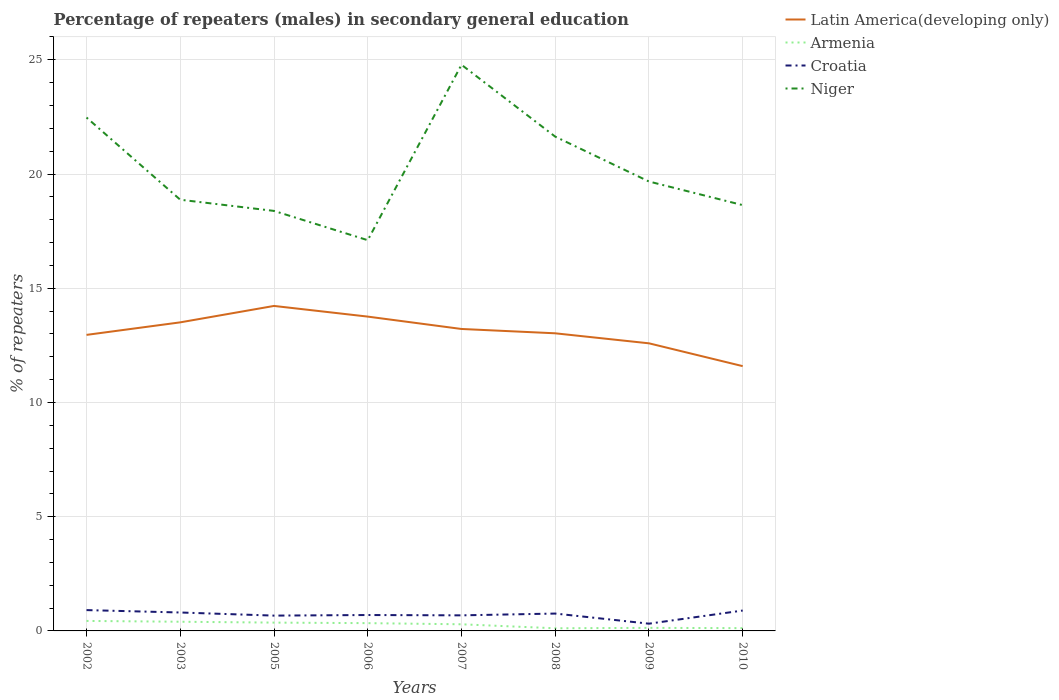How many different coloured lines are there?
Ensure brevity in your answer.  4. Does the line corresponding to Croatia intersect with the line corresponding to Niger?
Give a very brief answer. No. Across all years, what is the maximum percentage of male repeaters in Armenia?
Your response must be concise. 0.12. In which year was the percentage of male repeaters in Latin America(developing only) maximum?
Your answer should be very brief. 2010. What is the total percentage of male repeaters in Croatia in the graph?
Provide a short and direct response. 0.1. What is the difference between the highest and the second highest percentage of male repeaters in Niger?
Make the answer very short. 7.68. What is the difference between the highest and the lowest percentage of male repeaters in Niger?
Your answer should be compact. 3. How many lines are there?
Offer a terse response. 4. Are the values on the major ticks of Y-axis written in scientific E-notation?
Ensure brevity in your answer.  No. Where does the legend appear in the graph?
Provide a succinct answer. Top right. How many legend labels are there?
Provide a succinct answer. 4. How are the legend labels stacked?
Offer a very short reply. Vertical. What is the title of the graph?
Offer a terse response. Percentage of repeaters (males) in secondary general education. Does "Kenya" appear as one of the legend labels in the graph?
Keep it short and to the point. No. What is the label or title of the Y-axis?
Keep it short and to the point. % of repeaters. What is the % of repeaters of Latin America(developing only) in 2002?
Offer a very short reply. 12.96. What is the % of repeaters of Armenia in 2002?
Provide a succinct answer. 0.44. What is the % of repeaters in Croatia in 2002?
Your response must be concise. 0.91. What is the % of repeaters of Niger in 2002?
Give a very brief answer. 22.47. What is the % of repeaters of Latin America(developing only) in 2003?
Offer a terse response. 13.51. What is the % of repeaters of Armenia in 2003?
Provide a short and direct response. 0.4. What is the % of repeaters in Croatia in 2003?
Make the answer very short. 0.81. What is the % of repeaters in Niger in 2003?
Your response must be concise. 18.87. What is the % of repeaters in Latin America(developing only) in 2005?
Your answer should be compact. 14.23. What is the % of repeaters in Armenia in 2005?
Your answer should be compact. 0.36. What is the % of repeaters of Croatia in 2005?
Offer a very short reply. 0.67. What is the % of repeaters of Niger in 2005?
Your response must be concise. 18.39. What is the % of repeaters of Latin America(developing only) in 2006?
Ensure brevity in your answer.  13.76. What is the % of repeaters of Armenia in 2006?
Your answer should be compact. 0.34. What is the % of repeaters of Croatia in 2006?
Give a very brief answer. 0.7. What is the % of repeaters of Niger in 2006?
Make the answer very short. 17.1. What is the % of repeaters of Latin America(developing only) in 2007?
Offer a very short reply. 13.22. What is the % of repeaters of Armenia in 2007?
Give a very brief answer. 0.29. What is the % of repeaters of Croatia in 2007?
Offer a terse response. 0.68. What is the % of repeaters in Niger in 2007?
Offer a very short reply. 24.78. What is the % of repeaters of Latin America(developing only) in 2008?
Keep it short and to the point. 13.03. What is the % of repeaters in Armenia in 2008?
Make the answer very short. 0.12. What is the % of repeaters of Croatia in 2008?
Keep it short and to the point. 0.76. What is the % of repeaters in Niger in 2008?
Keep it short and to the point. 21.64. What is the % of repeaters of Latin America(developing only) in 2009?
Provide a succinct answer. 12.59. What is the % of repeaters in Armenia in 2009?
Your response must be concise. 0.13. What is the % of repeaters of Croatia in 2009?
Your response must be concise. 0.32. What is the % of repeaters of Niger in 2009?
Offer a very short reply. 19.67. What is the % of repeaters of Latin America(developing only) in 2010?
Offer a terse response. 11.59. What is the % of repeaters of Armenia in 2010?
Your answer should be very brief. 0.12. What is the % of repeaters of Croatia in 2010?
Your response must be concise. 0.89. What is the % of repeaters of Niger in 2010?
Your answer should be very brief. 18.64. Across all years, what is the maximum % of repeaters of Latin America(developing only)?
Your answer should be very brief. 14.23. Across all years, what is the maximum % of repeaters in Armenia?
Your response must be concise. 0.44. Across all years, what is the maximum % of repeaters in Croatia?
Provide a succinct answer. 0.91. Across all years, what is the maximum % of repeaters of Niger?
Provide a short and direct response. 24.78. Across all years, what is the minimum % of repeaters in Latin America(developing only)?
Keep it short and to the point. 11.59. Across all years, what is the minimum % of repeaters of Armenia?
Make the answer very short. 0.12. Across all years, what is the minimum % of repeaters in Croatia?
Keep it short and to the point. 0.32. Across all years, what is the minimum % of repeaters in Niger?
Your response must be concise. 17.1. What is the total % of repeaters in Latin America(developing only) in the graph?
Your answer should be compact. 104.88. What is the total % of repeaters of Armenia in the graph?
Give a very brief answer. 2.2. What is the total % of repeaters in Croatia in the graph?
Provide a short and direct response. 5.74. What is the total % of repeaters of Niger in the graph?
Offer a very short reply. 161.57. What is the difference between the % of repeaters of Latin America(developing only) in 2002 and that in 2003?
Your answer should be compact. -0.55. What is the difference between the % of repeaters in Armenia in 2002 and that in 2003?
Your answer should be compact. 0.04. What is the difference between the % of repeaters in Croatia in 2002 and that in 2003?
Keep it short and to the point. 0.1. What is the difference between the % of repeaters of Niger in 2002 and that in 2003?
Offer a terse response. 3.6. What is the difference between the % of repeaters in Latin America(developing only) in 2002 and that in 2005?
Your response must be concise. -1.27. What is the difference between the % of repeaters in Armenia in 2002 and that in 2005?
Make the answer very short. 0.07. What is the difference between the % of repeaters in Croatia in 2002 and that in 2005?
Provide a short and direct response. 0.24. What is the difference between the % of repeaters of Niger in 2002 and that in 2005?
Make the answer very short. 4.09. What is the difference between the % of repeaters in Latin America(developing only) in 2002 and that in 2006?
Your answer should be very brief. -0.8. What is the difference between the % of repeaters in Armenia in 2002 and that in 2006?
Provide a succinct answer. 0.1. What is the difference between the % of repeaters of Croatia in 2002 and that in 2006?
Keep it short and to the point. 0.22. What is the difference between the % of repeaters in Niger in 2002 and that in 2006?
Give a very brief answer. 5.37. What is the difference between the % of repeaters of Latin America(developing only) in 2002 and that in 2007?
Keep it short and to the point. -0.26. What is the difference between the % of repeaters in Armenia in 2002 and that in 2007?
Make the answer very short. 0.15. What is the difference between the % of repeaters in Croatia in 2002 and that in 2007?
Offer a very short reply. 0.23. What is the difference between the % of repeaters of Niger in 2002 and that in 2007?
Your response must be concise. -2.31. What is the difference between the % of repeaters in Latin America(developing only) in 2002 and that in 2008?
Give a very brief answer. -0.07. What is the difference between the % of repeaters in Armenia in 2002 and that in 2008?
Your response must be concise. 0.32. What is the difference between the % of repeaters of Croatia in 2002 and that in 2008?
Make the answer very short. 0.15. What is the difference between the % of repeaters in Niger in 2002 and that in 2008?
Make the answer very short. 0.84. What is the difference between the % of repeaters in Latin America(developing only) in 2002 and that in 2009?
Make the answer very short. 0.37. What is the difference between the % of repeaters of Armenia in 2002 and that in 2009?
Offer a very short reply. 0.3. What is the difference between the % of repeaters in Croatia in 2002 and that in 2009?
Your answer should be compact. 0.59. What is the difference between the % of repeaters in Niger in 2002 and that in 2009?
Provide a succinct answer. 2.8. What is the difference between the % of repeaters in Latin America(developing only) in 2002 and that in 2010?
Give a very brief answer. 1.37. What is the difference between the % of repeaters of Armenia in 2002 and that in 2010?
Make the answer very short. 0.32. What is the difference between the % of repeaters in Croatia in 2002 and that in 2010?
Your answer should be very brief. 0.02. What is the difference between the % of repeaters in Niger in 2002 and that in 2010?
Offer a very short reply. 3.83. What is the difference between the % of repeaters of Latin America(developing only) in 2003 and that in 2005?
Your answer should be very brief. -0.72. What is the difference between the % of repeaters of Armenia in 2003 and that in 2005?
Provide a short and direct response. 0.04. What is the difference between the % of repeaters of Croatia in 2003 and that in 2005?
Your answer should be very brief. 0.14. What is the difference between the % of repeaters in Niger in 2003 and that in 2005?
Give a very brief answer. 0.49. What is the difference between the % of repeaters of Latin America(developing only) in 2003 and that in 2006?
Give a very brief answer. -0.25. What is the difference between the % of repeaters in Armenia in 2003 and that in 2006?
Make the answer very short. 0.06. What is the difference between the % of repeaters of Croatia in 2003 and that in 2006?
Give a very brief answer. 0.11. What is the difference between the % of repeaters of Niger in 2003 and that in 2006?
Give a very brief answer. 1.77. What is the difference between the % of repeaters of Latin America(developing only) in 2003 and that in 2007?
Give a very brief answer. 0.29. What is the difference between the % of repeaters in Armenia in 2003 and that in 2007?
Offer a very short reply. 0.11. What is the difference between the % of repeaters in Croatia in 2003 and that in 2007?
Offer a terse response. 0.12. What is the difference between the % of repeaters of Niger in 2003 and that in 2007?
Ensure brevity in your answer.  -5.91. What is the difference between the % of repeaters of Latin America(developing only) in 2003 and that in 2008?
Ensure brevity in your answer.  0.48. What is the difference between the % of repeaters in Armenia in 2003 and that in 2008?
Your answer should be very brief. 0.29. What is the difference between the % of repeaters of Croatia in 2003 and that in 2008?
Give a very brief answer. 0.05. What is the difference between the % of repeaters in Niger in 2003 and that in 2008?
Your answer should be very brief. -2.76. What is the difference between the % of repeaters in Latin America(developing only) in 2003 and that in 2009?
Ensure brevity in your answer.  0.92. What is the difference between the % of repeaters in Armenia in 2003 and that in 2009?
Keep it short and to the point. 0.27. What is the difference between the % of repeaters of Croatia in 2003 and that in 2009?
Offer a terse response. 0.49. What is the difference between the % of repeaters in Niger in 2003 and that in 2009?
Provide a short and direct response. -0.8. What is the difference between the % of repeaters in Latin America(developing only) in 2003 and that in 2010?
Your response must be concise. 1.92. What is the difference between the % of repeaters in Armenia in 2003 and that in 2010?
Make the answer very short. 0.28. What is the difference between the % of repeaters in Croatia in 2003 and that in 2010?
Your answer should be compact. -0.09. What is the difference between the % of repeaters of Niger in 2003 and that in 2010?
Keep it short and to the point. 0.24. What is the difference between the % of repeaters of Latin America(developing only) in 2005 and that in 2006?
Ensure brevity in your answer.  0.47. What is the difference between the % of repeaters in Armenia in 2005 and that in 2006?
Your answer should be very brief. 0.02. What is the difference between the % of repeaters in Croatia in 2005 and that in 2006?
Offer a terse response. -0.03. What is the difference between the % of repeaters in Niger in 2005 and that in 2006?
Your answer should be compact. 1.28. What is the difference between the % of repeaters in Latin America(developing only) in 2005 and that in 2007?
Your response must be concise. 1.01. What is the difference between the % of repeaters in Armenia in 2005 and that in 2007?
Offer a terse response. 0.07. What is the difference between the % of repeaters in Croatia in 2005 and that in 2007?
Your response must be concise. -0.01. What is the difference between the % of repeaters of Niger in 2005 and that in 2007?
Provide a succinct answer. -6.4. What is the difference between the % of repeaters in Latin America(developing only) in 2005 and that in 2008?
Offer a terse response. 1.2. What is the difference between the % of repeaters of Armenia in 2005 and that in 2008?
Offer a very short reply. 0.25. What is the difference between the % of repeaters of Croatia in 2005 and that in 2008?
Ensure brevity in your answer.  -0.09. What is the difference between the % of repeaters of Niger in 2005 and that in 2008?
Ensure brevity in your answer.  -3.25. What is the difference between the % of repeaters in Latin America(developing only) in 2005 and that in 2009?
Make the answer very short. 1.64. What is the difference between the % of repeaters of Armenia in 2005 and that in 2009?
Offer a very short reply. 0.23. What is the difference between the % of repeaters in Croatia in 2005 and that in 2009?
Provide a succinct answer. 0.35. What is the difference between the % of repeaters in Niger in 2005 and that in 2009?
Your answer should be very brief. -1.29. What is the difference between the % of repeaters in Latin America(developing only) in 2005 and that in 2010?
Your response must be concise. 2.64. What is the difference between the % of repeaters of Armenia in 2005 and that in 2010?
Provide a short and direct response. 0.24. What is the difference between the % of repeaters of Croatia in 2005 and that in 2010?
Your response must be concise. -0.22. What is the difference between the % of repeaters of Niger in 2005 and that in 2010?
Ensure brevity in your answer.  -0.25. What is the difference between the % of repeaters in Latin America(developing only) in 2006 and that in 2007?
Ensure brevity in your answer.  0.54. What is the difference between the % of repeaters of Armenia in 2006 and that in 2007?
Make the answer very short. 0.05. What is the difference between the % of repeaters of Croatia in 2006 and that in 2007?
Offer a very short reply. 0.01. What is the difference between the % of repeaters in Niger in 2006 and that in 2007?
Your response must be concise. -7.68. What is the difference between the % of repeaters in Latin America(developing only) in 2006 and that in 2008?
Provide a succinct answer. 0.73. What is the difference between the % of repeaters of Armenia in 2006 and that in 2008?
Your answer should be very brief. 0.23. What is the difference between the % of repeaters in Croatia in 2006 and that in 2008?
Your answer should be compact. -0.06. What is the difference between the % of repeaters in Niger in 2006 and that in 2008?
Keep it short and to the point. -4.53. What is the difference between the % of repeaters in Latin America(developing only) in 2006 and that in 2009?
Offer a terse response. 1.17. What is the difference between the % of repeaters of Armenia in 2006 and that in 2009?
Offer a very short reply. 0.21. What is the difference between the % of repeaters in Croatia in 2006 and that in 2009?
Give a very brief answer. 0.38. What is the difference between the % of repeaters in Niger in 2006 and that in 2009?
Your response must be concise. -2.57. What is the difference between the % of repeaters of Latin America(developing only) in 2006 and that in 2010?
Provide a short and direct response. 2.17. What is the difference between the % of repeaters of Armenia in 2006 and that in 2010?
Offer a terse response. 0.22. What is the difference between the % of repeaters of Croatia in 2006 and that in 2010?
Give a very brief answer. -0.2. What is the difference between the % of repeaters of Niger in 2006 and that in 2010?
Keep it short and to the point. -1.54. What is the difference between the % of repeaters of Latin America(developing only) in 2007 and that in 2008?
Offer a terse response. 0.19. What is the difference between the % of repeaters in Armenia in 2007 and that in 2008?
Ensure brevity in your answer.  0.18. What is the difference between the % of repeaters of Croatia in 2007 and that in 2008?
Offer a very short reply. -0.08. What is the difference between the % of repeaters of Niger in 2007 and that in 2008?
Make the answer very short. 3.15. What is the difference between the % of repeaters of Latin America(developing only) in 2007 and that in 2009?
Give a very brief answer. 0.63. What is the difference between the % of repeaters of Armenia in 2007 and that in 2009?
Provide a succinct answer. 0.16. What is the difference between the % of repeaters in Croatia in 2007 and that in 2009?
Offer a terse response. 0.36. What is the difference between the % of repeaters of Niger in 2007 and that in 2009?
Keep it short and to the point. 5.11. What is the difference between the % of repeaters in Latin America(developing only) in 2007 and that in 2010?
Make the answer very short. 1.63. What is the difference between the % of repeaters in Armenia in 2007 and that in 2010?
Keep it short and to the point. 0.17. What is the difference between the % of repeaters of Croatia in 2007 and that in 2010?
Keep it short and to the point. -0.21. What is the difference between the % of repeaters of Niger in 2007 and that in 2010?
Ensure brevity in your answer.  6.14. What is the difference between the % of repeaters in Latin America(developing only) in 2008 and that in 2009?
Offer a very short reply. 0.44. What is the difference between the % of repeaters of Armenia in 2008 and that in 2009?
Give a very brief answer. -0.02. What is the difference between the % of repeaters in Croatia in 2008 and that in 2009?
Keep it short and to the point. 0.44. What is the difference between the % of repeaters of Niger in 2008 and that in 2009?
Ensure brevity in your answer.  1.96. What is the difference between the % of repeaters of Latin America(developing only) in 2008 and that in 2010?
Your answer should be very brief. 1.44. What is the difference between the % of repeaters in Armenia in 2008 and that in 2010?
Keep it short and to the point. -0.01. What is the difference between the % of repeaters of Croatia in 2008 and that in 2010?
Provide a succinct answer. -0.13. What is the difference between the % of repeaters of Niger in 2008 and that in 2010?
Make the answer very short. 3. What is the difference between the % of repeaters in Latin America(developing only) in 2009 and that in 2010?
Your response must be concise. 1. What is the difference between the % of repeaters of Armenia in 2009 and that in 2010?
Your answer should be compact. 0.01. What is the difference between the % of repeaters in Croatia in 2009 and that in 2010?
Offer a very short reply. -0.58. What is the difference between the % of repeaters in Niger in 2009 and that in 2010?
Make the answer very short. 1.03. What is the difference between the % of repeaters in Latin America(developing only) in 2002 and the % of repeaters in Armenia in 2003?
Make the answer very short. 12.56. What is the difference between the % of repeaters of Latin America(developing only) in 2002 and the % of repeaters of Croatia in 2003?
Make the answer very short. 12.15. What is the difference between the % of repeaters in Latin America(developing only) in 2002 and the % of repeaters in Niger in 2003?
Ensure brevity in your answer.  -5.92. What is the difference between the % of repeaters of Armenia in 2002 and the % of repeaters of Croatia in 2003?
Offer a terse response. -0.37. What is the difference between the % of repeaters of Armenia in 2002 and the % of repeaters of Niger in 2003?
Offer a terse response. -18.44. What is the difference between the % of repeaters of Croatia in 2002 and the % of repeaters of Niger in 2003?
Offer a very short reply. -17.96. What is the difference between the % of repeaters of Latin America(developing only) in 2002 and the % of repeaters of Armenia in 2005?
Your answer should be compact. 12.59. What is the difference between the % of repeaters of Latin America(developing only) in 2002 and the % of repeaters of Croatia in 2005?
Provide a succinct answer. 12.29. What is the difference between the % of repeaters in Latin America(developing only) in 2002 and the % of repeaters in Niger in 2005?
Provide a succinct answer. -5.43. What is the difference between the % of repeaters in Armenia in 2002 and the % of repeaters in Croatia in 2005?
Ensure brevity in your answer.  -0.23. What is the difference between the % of repeaters of Armenia in 2002 and the % of repeaters of Niger in 2005?
Give a very brief answer. -17.95. What is the difference between the % of repeaters in Croatia in 2002 and the % of repeaters in Niger in 2005?
Ensure brevity in your answer.  -17.47. What is the difference between the % of repeaters in Latin America(developing only) in 2002 and the % of repeaters in Armenia in 2006?
Your answer should be compact. 12.62. What is the difference between the % of repeaters in Latin America(developing only) in 2002 and the % of repeaters in Croatia in 2006?
Offer a very short reply. 12.26. What is the difference between the % of repeaters of Latin America(developing only) in 2002 and the % of repeaters of Niger in 2006?
Your response must be concise. -4.14. What is the difference between the % of repeaters in Armenia in 2002 and the % of repeaters in Croatia in 2006?
Provide a succinct answer. -0.26. What is the difference between the % of repeaters of Armenia in 2002 and the % of repeaters of Niger in 2006?
Your response must be concise. -16.67. What is the difference between the % of repeaters in Croatia in 2002 and the % of repeaters in Niger in 2006?
Offer a very short reply. -16.19. What is the difference between the % of repeaters in Latin America(developing only) in 2002 and the % of repeaters in Armenia in 2007?
Provide a short and direct response. 12.67. What is the difference between the % of repeaters in Latin America(developing only) in 2002 and the % of repeaters in Croatia in 2007?
Provide a succinct answer. 12.28. What is the difference between the % of repeaters of Latin America(developing only) in 2002 and the % of repeaters of Niger in 2007?
Make the answer very short. -11.83. What is the difference between the % of repeaters of Armenia in 2002 and the % of repeaters of Croatia in 2007?
Make the answer very short. -0.24. What is the difference between the % of repeaters in Armenia in 2002 and the % of repeaters in Niger in 2007?
Offer a terse response. -24.35. What is the difference between the % of repeaters of Croatia in 2002 and the % of repeaters of Niger in 2007?
Provide a short and direct response. -23.87. What is the difference between the % of repeaters of Latin America(developing only) in 2002 and the % of repeaters of Armenia in 2008?
Your response must be concise. 12.84. What is the difference between the % of repeaters in Latin America(developing only) in 2002 and the % of repeaters in Croatia in 2008?
Keep it short and to the point. 12.2. What is the difference between the % of repeaters in Latin America(developing only) in 2002 and the % of repeaters in Niger in 2008?
Provide a short and direct response. -8.68. What is the difference between the % of repeaters of Armenia in 2002 and the % of repeaters of Croatia in 2008?
Provide a short and direct response. -0.32. What is the difference between the % of repeaters of Armenia in 2002 and the % of repeaters of Niger in 2008?
Your answer should be very brief. -21.2. What is the difference between the % of repeaters of Croatia in 2002 and the % of repeaters of Niger in 2008?
Your answer should be very brief. -20.73. What is the difference between the % of repeaters of Latin America(developing only) in 2002 and the % of repeaters of Armenia in 2009?
Provide a short and direct response. 12.82. What is the difference between the % of repeaters in Latin America(developing only) in 2002 and the % of repeaters in Croatia in 2009?
Your answer should be compact. 12.64. What is the difference between the % of repeaters in Latin America(developing only) in 2002 and the % of repeaters in Niger in 2009?
Make the answer very short. -6.71. What is the difference between the % of repeaters of Armenia in 2002 and the % of repeaters of Croatia in 2009?
Provide a succinct answer. 0.12. What is the difference between the % of repeaters of Armenia in 2002 and the % of repeaters of Niger in 2009?
Make the answer very short. -19.23. What is the difference between the % of repeaters in Croatia in 2002 and the % of repeaters in Niger in 2009?
Keep it short and to the point. -18.76. What is the difference between the % of repeaters of Latin America(developing only) in 2002 and the % of repeaters of Armenia in 2010?
Ensure brevity in your answer.  12.84. What is the difference between the % of repeaters in Latin America(developing only) in 2002 and the % of repeaters in Croatia in 2010?
Keep it short and to the point. 12.07. What is the difference between the % of repeaters of Latin America(developing only) in 2002 and the % of repeaters of Niger in 2010?
Your answer should be compact. -5.68. What is the difference between the % of repeaters in Armenia in 2002 and the % of repeaters in Croatia in 2010?
Your response must be concise. -0.46. What is the difference between the % of repeaters of Armenia in 2002 and the % of repeaters of Niger in 2010?
Provide a succinct answer. -18.2. What is the difference between the % of repeaters of Croatia in 2002 and the % of repeaters of Niger in 2010?
Give a very brief answer. -17.73. What is the difference between the % of repeaters in Latin America(developing only) in 2003 and the % of repeaters in Armenia in 2005?
Provide a succinct answer. 13.14. What is the difference between the % of repeaters in Latin America(developing only) in 2003 and the % of repeaters in Croatia in 2005?
Give a very brief answer. 12.84. What is the difference between the % of repeaters of Latin America(developing only) in 2003 and the % of repeaters of Niger in 2005?
Make the answer very short. -4.88. What is the difference between the % of repeaters of Armenia in 2003 and the % of repeaters of Croatia in 2005?
Your response must be concise. -0.27. What is the difference between the % of repeaters in Armenia in 2003 and the % of repeaters in Niger in 2005?
Provide a short and direct response. -17.98. What is the difference between the % of repeaters of Croatia in 2003 and the % of repeaters of Niger in 2005?
Your response must be concise. -17.58. What is the difference between the % of repeaters in Latin America(developing only) in 2003 and the % of repeaters in Armenia in 2006?
Your response must be concise. 13.17. What is the difference between the % of repeaters in Latin America(developing only) in 2003 and the % of repeaters in Croatia in 2006?
Make the answer very short. 12.81. What is the difference between the % of repeaters in Latin America(developing only) in 2003 and the % of repeaters in Niger in 2006?
Ensure brevity in your answer.  -3.6. What is the difference between the % of repeaters of Armenia in 2003 and the % of repeaters of Croatia in 2006?
Offer a very short reply. -0.29. What is the difference between the % of repeaters in Armenia in 2003 and the % of repeaters in Niger in 2006?
Keep it short and to the point. -16.7. What is the difference between the % of repeaters in Croatia in 2003 and the % of repeaters in Niger in 2006?
Your answer should be compact. -16.3. What is the difference between the % of repeaters of Latin America(developing only) in 2003 and the % of repeaters of Armenia in 2007?
Your response must be concise. 13.22. What is the difference between the % of repeaters in Latin America(developing only) in 2003 and the % of repeaters in Croatia in 2007?
Your answer should be compact. 12.83. What is the difference between the % of repeaters of Latin America(developing only) in 2003 and the % of repeaters of Niger in 2007?
Your response must be concise. -11.28. What is the difference between the % of repeaters of Armenia in 2003 and the % of repeaters of Croatia in 2007?
Your answer should be very brief. -0.28. What is the difference between the % of repeaters of Armenia in 2003 and the % of repeaters of Niger in 2007?
Make the answer very short. -24.38. What is the difference between the % of repeaters in Croatia in 2003 and the % of repeaters in Niger in 2007?
Your answer should be compact. -23.98. What is the difference between the % of repeaters of Latin America(developing only) in 2003 and the % of repeaters of Armenia in 2008?
Your answer should be very brief. 13.39. What is the difference between the % of repeaters of Latin America(developing only) in 2003 and the % of repeaters of Croatia in 2008?
Offer a terse response. 12.75. What is the difference between the % of repeaters in Latin America(developing only) in 2003 and the % of repeaters in Niger in 2008?
Your response must be concise. -8.13. What is the difference between the % of repeaters in Armenia in 2003 and the % of repeaters in Croatia in 2008?
Give a very brief answer. -0.36. What is the difference between the % of repeaters in Armenia in 2003 and the % of repeaters in Niger in 2008?
Provide a succinct answer. -21.24. What is the difference between the % of repeaters of Croatia in 2003 and the % of repeaters of Niger in 2008?
Provide a succinct answer. -20.83. What is the difference between the % of repeaters of Latin America(developing only) in 2003 and the % of repeaters of Armenia in 2009?
Ensure brevity in your answer.  13.37. What is the difference between the % of repeaters in Latin America(developing only) in 2003 and the % of repeaters in Croatia in 2009?
Your answer should be very brief. 13.19. What is the difference between the % of repeaters in Latin America(developing only) in 2003 and the % of repeaters in Niger in 2009?
Provide a short and direct response. -6.16. What is the difference between the % of repeaters in Armenia in 2003 and the % of repeaters in Croatia in 2009?
Provide a short and direct response. 0.08. What is the difference between the % of repeaters in Armenia in 2003 and the % of repeaters in Niger in 2009?
Ensure brevity in your answer.  -19.27. What is the difference between the % of repeaters of Croatia in 2003 and the % of repeaters of Niger in 2009?
Make the answer very short. -18.87. What is the difference between the % of repeaters of Latin America(developing only) in 2003 and the % of repeaters of Armenia in 2010?
Your answer should be very brief. 13.39. What is the difference between the % of repeaters in Latin America(developing only) in 2003 and the % of repeaters in Croatia in 2010?
Offer a terse response. 12.62. What is the difference between the % of repeaters in Latin America(developing only) in 2003 and the % of repeaters in Niger in 2010?
Offer a terse response. -5.13. What is the difference between the % of repeaters in Armenia in 2003 and the % of repeaters in Croatia in 2010?
Keep it short and to the point. -0.49. What is the difference between the % of repeaters of Armenia in 2003 and the % of repeaters of Niger in 2010?
Make the answer very short. -18.24. What is the difference between the % of repeaters of Croatia in 2003 and the % of repeaters of Niger in 2010?
Your answer should be compact. -17.83. What is the difference between the % of repeaters of Latin America(developing only) in 2005 and the % of repeaters of Armenia in 2006?
Make the answer very short. 13.89. What is the difference between the % of repeaters of Latin America(developing only) in 2005 and the % of repeaters of Croatia in 2006?
Offer a very short reply. 13.53. What is the difference between the % of repeaters of Latin America(developing only) in 2005 and the % of repeaters of Niger in 2006?
Make the answer very short. -2.88. What is the difference between the % of repeaters in Armenia in 2005 and the % of repeaters in Croatia in 2006?
Provide a short and direct response. -0.33. What is the difference between the % of repeaters of Armenia in 2005 and the % of repeaters of Niger in 2006?
Provide a succinct answer. -16.74. What is the difference between the % of repeaters of Croatia in 2005 and the % of repeaters of Niger in 2006?
Offer a terse response. -16.43. What is the difference between the % of repeaters of Latin America(developing only) in 2005 and the % of repeaters of Armenia in 2007?
Provide a short and direct response. 13.94. What is the difference between the % of repeaters of Latin America(developing only) in 2005 and the % of repeaters of Croatia in 2007?
Your answer should be very brief. 13.54. What is the difference between the % of repeaters in Latin America(developing only) in 2005 and the % of repeaters in Niger in 2007?
Make the answer very short. -10.56. What is the difference between the % of repeaters in Armenia in 2005 and the % of repeaters in Croatia in 2007?
Offer a very short reply. -0.32. What is the difference between the % of repeaters in Armenia in 2005 and the % of repeaters in Niger in 2007?
Provide a succinct answer. -24.42. What is the difference between the % of repeaters in Croatia in 2005 and the % of repeaters in Niger in 2007?
Provide a short and direct response. -24.11. What is the difference between the % of repeaters of Latin America(developing only) in 2005 and the % of repeaters of Armenia in 2008?
Your answer should be very brief. 14.11. What is the difference between the % of repeaters in Latin America(developing only) in 2005 and the % of repeaters in Croatia in 2008?
Your answer should be compact. 13.47. What is the difference between the % of repeaters of Latin America(developing only) in 2005 and the % of repeaters of Niger in 2008?
Offer a terse response. -7.41. What is the difference between the % of repeaters of Armenia in 2005 and the % of repeaters of Croatia in 2008?
Make the answer very short. -0.4. What is the difference between the % of repeaters of Armenia in 2005 and the % of repeaters of Niger in 2008?
Provide a short and direct response. -21.27. What is the difference between the % of repeaters in Croatia in 2005 and the % of repeaters in Niger in 2008?
Ensure brevity in your answer.  -20.97. What is the difference between the % of repeaters of Latin America(developing only) in 2005 and the % of repeaters of Armenia in 2009?
Your answer should be very brief. 14.09. What is the difference between the % of repeaters in Latin America(developing only) in 2005 and the % of repeaters in Croatia in 2009?
Your response must be concise. 13.91. What is the difference between the % of repeaters of Latin America(developing only) in 2005 and the % of repeaters of Niger in 2009?
Provide a succinct answer. -5.45. What is the difference between the % of repeaters of Armenia in 2005 and the % of repeaters of Croatia in 2009?
Keep it short and to the point. 0.05. What is the difference between the % of repeaters in Armenia in 2005 and the % of repeaters in Niger in 2009?
Provide a short and direct response. -19.31. What is the difference between the % of repeaters in Croatia in 2005 and the % of repeaters in Niger in 2009?
Keep it short and to the point. -19. What is the difference between the % of repeaters of Latin America(developing only) in 2005 and the % of repeaters of Armenia in 2010?
Provide a succinct answer. 14.1. What is the difference between the % of repeaters of Latin America(developing only) in 2005 and the % of repeaters of Croatia in 2010?
Your answer should be compact. 13.33. What is the difference between the % of repeaters of Latin America(developing only) in 2005 and the % of repeaters of Niger in 2010?
Your response must be concise. -4.41. What is the difference between the % of repeaters in Armenia in 2005 and the % of repeaters in Croatia in 2010?
Keep it short and to the point. -0.53. What is the difference between the % of repeaters in Armenia in 2005 and the % of repeaters in Niger in 2010?
Provide a succinct answer. -18.28. What is the difference between the % of repeaters of Croatia in 2005 and the % of repeaters of Niger in 2010?
Provide a succinct answer. -17.97. What is the difference between the % of repeaters in Latin America(developing only) in 2006 and the % of repeaters in Armenia in 2007?
Keep it short and to the point. 13.47. What is the difference between the % of repeaters in Latin America(developing only) in 2006 and the % of repeaters in Croatia in 2007?
Make the answer very short. 13.08. What is the difference between the % of repeaters in Latin America(developing only) in 2006 and the % of repeaters in Niger in 2007?
Give a very brief answer. -11.02. What is the difference between the % of repeaters of Armenia in 2006 and the % of repeaters of Croatia in 2007?
Your response must be concise. -0.34. What is the difference between the % of repeaters of Armenia in 2006 and the % of repeaters of Niger in 2007?
Your answer should be compact. -24.44. What is the difference between the % of repeaters in Croatia in 2006 and the % of repeaters in Niger in 2007?
Provide a succinct answer. -24.09. What is the difference between the % of repeaters of Latin America(developing only) in 2006 and the % of repeaters of Armenia in 2008?
Provide a short and direct response. 13.64. What is the difference between the % of repeaters in Latin America(developing only) in 2006 and the % of repeaters in Croatia in 2008?
Ensure brevity in your answer.  13. What is the difference between the % of repeaters in Latin America(developing only) in 2006 and the % of repeaters in Niger in 2008?
Give a very brief answer. -7.88. What is the difference between the % of repeaters in Armenia in 2006 and the % of repeaters in Croatia in 2008?
Offer a very short reply. -0.42. What is the difference between the % of repeaters of Armenia in 2006 and the % of repeaters of Niger in 2008?
Your answer should be very brief. -21.3. What is the difference between the % of repeaters in Croatia in 2006 and the % of repeaters in Niger in 2008?
Ensure brevity in your answer.  -20.94. What is the difference between the % of repeaters in Latin America(developing only) in 2006 and the % of repeaters in Armenia in 2009?
Make the answer very short. 13.62. What is the difference between the % of repeaters of Latin America(developing only) in 2006 and the % of repeaters of Croatia in 2009?
Your answer should be compact. 13.44. What is the difference between the % of repeaters of Latin America(developing only) in 2006 and the % of repeaters of Niger in 2009?
Your answer should be very brief. -5.91. What is the difference between the % of repeaters in Armenia in 2006 and the % of repeaters in Croatia in 2009?
Provide a short and direct response. 0.02. What is the difference between the % of repeaters in Armenia in 2006 and the % of repeaters in Niger in 2009?
Offer a terse response. -19.33. What is the difference between the % of repeaters of Croatia in 2006 and the % of repeaters of Niger in 2009?
Offer a terse response. -18.98. What is the difference between the % of repeaters of Latin America(developing only) in 2006 and the % of repeaters of Armenia in 2010?
Keep it short and to the point. 13.64. What is the difference between the % of repeaters in Latin America(developing only) in 2006 and the % of repeaters in Croatia in 2010?
Provide a succinct answer. 12.87. What is the difference between the % of repeaters of Latin America(developing only) in 2006 and the % of repeaters of Niger in 2010?
Keep it short and to the point. -4.88. What is the difference between the % of repeaters in Armenia in 2006 and the % of repeaters in Croatia in 2010?
Ensure brevity in your answer.  -0.55. What is the difference between the % of repeaters in Armenia in 2006 and the % of repeaters in Niger in 2010?
Provide a succinct answer. -18.3. What is the difference between the % of repeaters of Croatia in 2006 and the % of repeaters of Niger in 2010?
Provide a short and direct response. -17.94. What is the difference between the % of repeaters of Latin America(developing only) in 2007 and the % of repeaters of Armenia in 2008?
Ensure brevity in your answer.  13.1. What is the difference between the % of repeaters of Latin America(developing only) in 2007 and the % of repeaters of Croatia in 2008?
Ensure brevity in your answer.  12.46. What is the difference between the % of repeaters in Latin America(developing only) in 2007 and the % of repeaters in Niger in 2008?
Offer a terse response. -8.42. What is the difference between the % of repeaters of Armenia in 2007 and the % of repeaters of Croatia in 2008?
Provide a short and direct response. -0.47. What is the difference between the % of repeaters in Armenia in 2007 and the % of repeaters in Niger in 2008?
Keep it short and to the point. -21.35. What is the difference between the % of repeaters in Croatia in 2007 and the % of repeaters in Niger in 2008?
Offer a terse response. -20.96. What is the difference between the % of repeaters in Latin America(developing only) in 2007 and the % of repeaters in Armenia in 2009?
Provide a short and direct response. 13.08. What is the difference between the % of repeaters in Latin America(developing only) in 2007 and the % of repeaters in Croatia in 2009?
Your response must be concise. 12.9. What is the difference between the % of repeaters in Latin America(developing only) in 2007 and the % of repeaters in Niger in 2009?
Your answer should be compact. -6.45. What is the difference between the % of repeaters in Armenia in 2007 and the % of repeaters in Croatia in 2009?
Make the answer very short. -0.03. What is the difference between the % of repeaters in Armenia in 2007 and the % of repeaters in Niger in 2009?
Keep it short and to the point. -19.38. What is the difference between the % of repeaters of Croatia in 2007 and the % of repeaters of Niger in 2009?
Keep it short and to the point. -18.99. What is the difference between the % of repeaters of Latin America(developing only) in 2007 and the % of repeaters of Armenia in 2010?
Your answer should be compact. 13.1. What is the difference between the % of repeaters of Latin America(developing only) in 2007 and the % of repeaters of Croatia in 2010?
Give a very brief answer. 12.33. What is the difference between the % of repeaters in Latin America(developing only) in 2007 and the % of repeaters in Niger in 2010?
Offer a terse response. -5.42. What is the difference between the % of repeaters of Armenia in 2007 and the % of repeaters of Croatia in 2010?
Provide a short and direct response. -0.6. What is the difference between the % of repeaters of Armenia in 2007 and the % of repeaters of Niger in 2010?
Your answer should be compact. -18.35. What is the difference between the % of repeaters in Croatia in 2007 and the % of repeaters in Niger in 2010?
Your answer should be very brief. -17.96. What is the difference between the % of repeaters of Latin America(developing only) in 2008 and the % of repeaters of Armenia in 2009?
Make the answer very short. 12.89. What is the difference between the % of repeaters of Latin America(developing only) in 2008 and the % of repeaters of Croatia in 2009?
Provide a succinct answer. 12.71. What is the difference between the % of repeaters of Latin America(developing only) in 2008 and the % of repeaters of Niger in 2009?
Give a very brief answer. -6.64. What is the difference between the % of repeaters in Armenia in 2008 and the % of repeaters in Croatia in 2009?
Your answer should be compact. -0.2. What is the difference between the % of repeaters of Armenia in 2008 and the % of repeaters of Niger in 2009?
Your answer should be very brief. -19.56. What is the difference between the % of repeaters in Croatia in 2008 and the % of repeaters in Niger in 2009?
Offer a very short reply. -18.91. What is the difference between the % of repeaters of Latin America(developing only) in 2008 and the % of repeaters of Armenia in 2010?
Make the answer very short. 12.91. What is the difference between the % of repeaters of Latin America(developing only) in 2008 and the % of repeaters of Croatia in 2010?
Your answer should be very brief. 12.14. What is the difference between the % of repeaters in Latin America(developing only) in 2008 and the % of repeaters in Niger in 2010?
Ensure brevity in your answer.  -5.61. What is the difference between the % of repeaters of Armenia in 2008 and the % of repeaters of Croatia in 2010?
Your answer should be very brief. -0.78. What is the difference between the % of repeaters in Armenia in 2008 and the % of repeaters in Niger in 2010?
Your response must be concise. -18.52. What is the difference between the % of repeaters of Croatia in 2008 and the % of repeaters of Niger in 2010?
Give a very brief answer. -17.88. What is the difference between the % of repeaters in Latin America(developing only) in 2009 and the % of repeaters in Armenia in 2010?
Your answer should be very brief. 12.47. What is the difference between the % of repeaters of Latin America(developing only) in 2009 and the % of repeaters of Croatia in 2010?
Ensure brevity in your answer.  11.7. What is the difference between the % of repeaters of Latin America(developing only) in 2009 and the % of repeaters of Niger in 2010?
Your answer should be very brief. -6.05. What is the difference between the % of repeaters of Armenia in 2009 and the % of repeaters of Croatia in 2010?
Your answer should be compact. -0.76. What is the difference between the % of repeaters of Armenia in 2009 and the % of repeaters of Niger in 2010?
Provide a short and direct response. -18.5. What is the difference between the % of repeaters in Croatia in 2009 and the % of repeaters in Niger in 2010?
Keep it short and to the point. -18.32. What is the average % of repeaters in Latin America(developing only) per year?
Ensure brevity in your answer.  13.11. What is the average % of repeaters in Armenia per year?
Offer a very short reply. 0.28. What is the average % of repeaters of Croatia per year?
Ensure brevity in your answer.  0.72. What is the average % of repeaters in Niger per year?
Your response must be concise. 20.2. In the year 2002, what is the difference between the % of repeaters of Latin America(developing only) and % of repeaters of Armenia?
Provide a succinct answer. 12.52. In the year 2002, what is the difference between the % of repeaters of Latin America(developing only) and % of repeaters of Croatia?
Keep it short and to the point. 12.05. In the year 2002, what is the difference between the % of repeaters in Latin America(developing only) and % of repeaters in Niger?
Your answer should be compact. -9.51. In the year 2002, what is the difference between the % of repeaters of Armenia and % of repeaters of Croatia?
Your response must be concise. -0.47. In the year 2002, what is the difference between the % of repeaters in Armenia and % of repeaters in Niger?
Your answer should be compact. -22.04. In the year 2002, what is the difference between the % of repeaters of Croatia and % of repeaters of Niger?
Provide a short and direct response. -21.56. In the year 2003, what is the difference between the % of repeaters of Latin America(developing only) and % of repeaters of Armenia?
Your response must be concise. 13.11. In the year 2003, what is the difference between the % of repeaters in Latin America(developing only) and % of repeaters in Croatia?
Provide a short and direct response. 12.7. In the year 2003, what is the difference between the % of repeaters of Latin America(developing only) and % of repeaters of Niger?
Your answer should be compact. -5.37. In the year 2003, what is the difference between the % of repeaters in Armenia and % of repeaters in Croatia?
Make the answer very short. -0.4. In the year 2003, what is the difference between the % of repeaters in Armenia and % of repeaters in Niger?
Your answer should be very brief. -18.47. In the year 2003, what is the difference between the % of repeaters of Croatia and % of repeaters of Niger?
Ensure brevity in your answer.  -18.07. In the year 2005, what is the difference between the % of repeaters of Latin America(developing only) and % of repeaters of Armenia?
Make the answer very short. 13.86. In the year 2005, what is the difference between the % of repeaters in Latin America(developing only) and % of repeaters in Croatia?
Provide a short and direct response. 13.56. In the year 2005, what is the difference between the % of repeaters of Latin America(developing only) and % of repeaters of Niger?
Your answer should be compact. -4.16. In the year 2005, what is the difference between the % of repeaters in Armenia and % of repeaters in Croatia?
Keep it short and to the point. -0.31. In the year 2005, what is the difference between the % of repeaters of Armenia and % of repeaters of Niger?
Offer a very short reply. -18.02. In the year 2005, what is the difference between the % of repeaters of Croatia and % of repeaters of Niger?
Your response must be concise. -17.72. In the year 2006, what is the difference between the % of repeaters of Latin America(developing only) and % of repeaters of Armenia?
Give a very brief answer. 13.42. In the year 2006, what is the difference between the % of repeaters in Latin America(developing only) and % of repeaters in Croatia?
Offer a terse response. 13.06. In the year 2006, what is the difference between the % of repeaters of Latin America(developing only) and % of repeaters of Niger?
Offer a very short reply. -3.34. In the year 2006, what is the difference between the % of repeaters of Armenia and % of repeaters of Croatia?
Make the answer very short. -0.36. In the year 2006, what is the difference between the % of repeaters in Armenia and % of repeaters in Niger?
Offer a very short reply. -16.76. In the year 2006, what is the difference between the % of repeaters in Croatia and % of repeaters in Niger?
Your answer should be compact. -16.41. In the year 2007, what is the difference between the % of repeaters of Latin America(developing only) and % of repeaters of Armenia?
Offer a very short reply. 12.93. In the year 2007, what is the difference between the % of repeaters of Latin America(developing only) and % of repeaters of Croatia?
Your answer should be compact. 12.54. In the year 2007, what is the difference between the % of repeaters of Latin America(developing only) and % of repeaters of Niger?
Offer a very short reply. -11.57. In the year 2007, what is the difference between the % of repeaters of Armenia and % of repeaters of Croatia?
Offer a very short reply. -0.39. In the year 2007, what is the difference between the % of repeaters in Armenia and % of repeaters in Niger?
Your response must be concise. -24.49. In the year 2007, what is the difference between the % of repeaters of Croatia and % of repeaters of Niger?
Provide a short and direct response. -24.1. In the year 2008, what is the difference between the % of repeaters in Latin America(developing only) and % of repeaters in Armenia?
Provide a succinct answer. 12.91. In the year 2008, what is the difference between the % of repeaters of Latin America(developing only) and % of repeaters of Croatia?
Make the answer very short. 12.27. In the year 2008, what is the difference between the % of repeaters of Latin America(developing only) and % of repeaters of Niger?
Provide a short and direct response. -8.61. In the year 2008, what is the difference between the % of repeaters in Armenia and % of repeaters in Croatia?
Ensure brevity in your answer.  -0.64. In the year 2008, what is the difference between the % of repeaters in Armenia and % of repeaters in Niger?
Your answer should be very brief. -21.52. In the year 2008, what is the difference between the % of repeaters of Croatia and % of repeaters of Niger?
Your answer should be very brief. -20.88. In the year 2009, what is the difference between the % of repeaters of Latin America(developing only) and % of repeaters of Armenia?
Your answer should be compact. 12.46. In the year 2009, what is the difference between the % of repeaters of Latin America(developing only) and % of repeaters of Croatia?
Your response must be concise. 12.27. In the year 2009, what is the difference between the % of repeaters of Latin America(developing only) and % of repeaters of Niger?
Your answer should be very brief. -7.08. In the year 2009, what is the difference between the % of repeaters in Armenia and % of repeaters in Croatia?
Your answer should be very brief. -0.18. In the year 2009, what is the difference between the % of repeaters in Armenia and % of repeaters in Niger?
Ensure brevity in your answer.  -19.54. In the year 2009, what is the difference between the % of repeaters in Croatia and % of repeaters in Niger?
Your answer should be very brief. -19.36. In the year 2010, what is the difference between the % of repeaters of Latin America(developing only) and % of repeaters of Armenia?
Your answer should be compact. 11.47. In the year 2010, what is the difference between the % of repeaters of Latin America(developing only) and % of repeaters of Croatia?
Keep it short and to the point. 10.7. In the year 2010, what is the difference between the % of repeaters in Latin America(developing only) and % of repeaters in Niger?
Give a very brief answer. -7.05. In the year 2010, what is the difference between the % of repeaters in Armenia and % of repeaters in Croatia?
Offer a terse response. -0.77. In the year 2010, what is the difference between the % of repeaters in Armenia and % of repeaters in Niger?
Keep it short and to the point. -18.52. In the year 2010, what is the difference between the % of repeaters of Croatia and % of repeaters of Niger?
Keep it short and to the point. -17.75. What is the ratio of the % of repeaters of Latin America(developing only) in 2002 to that in 2003?
Ensure brevity in your answer.  0.96. What is the ratio of the % of repeaters of Armenia in 2002 to that in 2003?
Your answer should be compact. 1.09. What is the ratio of the % of repeaters in Croatia in 2002 to that in 2003?
Provide a succinct answer. 1.13. What is the ratio of the % of repeaters of Niger in 2002 to that in 2003?
Give a very brief answer. 1.19. What is the ratio of the % of repeaters in Latin America(developing only) in 2002 to that in 2005?
Offer a very short reply. 0.91. What is the ratio of the % of repeaters in Armenia in 2002 to that in 2005?
Ensure brevity in your answer.  1.2. What is the ratio of the % of repeaters in Croatia in 2002 to that in 2005?
Provide a short and direct response. 1.36. What is the ratio of the % of repeaters of Niger in 2002 to that in 2005?
Your response must be concise. 1.22. What is the ratio of the % of repeaters of Latin America(developing only) in 2002 to that in 2006?
Offer a very short reply. 0.94. What is the ratio of the % of repeaters of Armenia in 2002 to that in 2006?
Offer a terse response. 1.28. What is the ratio of the % of repeaters in Croatia in 2002 to that in 2006?
Provide a short and direct response. 1.31. What is the ratio of the % of repeaters of Niger in 2002 to that in 2006?
Give a very brief answer. 1.31. What is the ratio of the % of repeaters of Latin America(developing only) in 2002 to that in 2007?
Provide a short and direct response. 0.98. What is the ratio of the % of repeaters in Armenia in 2002 to that in 2007?
Offer a terse response. 1.51. What is the ratio of the % of repeaters of Croatia in 2002 to that in 2007?
Your answer should be compact. 1.34. What is the ratio of the % of repeaters of Niger in 2002 to that in 2007?
Ensure brevity in your answer.  0.91. What is the ratio of the % of repeaters of Latin America(developing only) in 2002 to that in 2008?
Offer a very short reply. 0.99. What is the ratio of the % of repeaters of Armenia in 2002 to that in 2008?
Keep it short and to the point. 3.79. What is the ratio of the % of repeaters in Croatia in 2002 to that in 2008?
Your answer should be very brief. 1.2. What is the ratio of the % of repeaters of Niger in 2002 to that in 2008?
Offer a very short reply. 1.04. What is the ratio of the % of repeaters in Latin America(developing only) in 2002 to that in 2009?
Your response must be concise. 1.03. What is the ratio of the % of repeaters in Armenia in 2002 to that in 2009?
Provide a short and direct response. 3.25. What is the ratio of the % of repeaters in Croatia in 2002 to that in 2009?
Provide a succinct answer. 2.88. What is the ratio of the % of repeaters in Niger in 2002 to that in 2009?
Provide a short and direct response. 1.14. What is the ratio of the % of repeaters in Latin America(developing only) in 2002 to that in 2010?
Offer a terse response. 1.12. What is the ratio of the % of repeaters in Armenia in 2002 to that in 2010?
Your answer should be compact. 3.61. What is the ratio of the % of repeaters of Croatia in 2002 to that in 2010?
Offer a very short reply. 1.02. What is the ratio of the % of repeaters in Niger in 2002 to that in 2010?
Ensure brevity in your answer.  1.21. What is the ratio of the % of repeaters of Latin America(developing only) in 2003 to that in 2005?
Keep it short and to the point. 0.95. What is the ratio of the % of repeaters in Armenia in 2003 to that in 2005?
Give a very brief answer. 1.1. What is the ratio of the % of repeaters in Croatia in 2003 to that in 2005?
Provide a succinct answer. 1.2. What is the ratio of the % of repeaters in Niger in 2003 to that in 2005?
Your response must be concise. 1.03. What is the ratio of the % of repeaters of Latin America(developing only) in 2003 to that in 2006?
Keep it short and to the point. 0.98. What is the ratio of the % of repeaters of Armenia in 2003 to that in 2006?
Offer a very short reply. 1.18. What is the ratio of the % of repeaters of Croatia in 2003 to that in 2006?
Ensure brevity in your answer.  1.16. What is the ratio of the % of repeaters of Niger in 2003 to that in 2006?
Provide a short and direct response. 1.1. What is the ratio of the % of repeaters in Latin America(developing only) in 2003 to that in 2007?
Offer a very short reply. 1.02. What is the ratio of the % of repeaters of Armenia in 2003 to that in 2007?
Your answer should be very brief. 1.38. What is the ratio of the % of repeaters in Croatia in 2003 to that in 2007?
Ensure brevity in your answer.  1.18. What is the ratio of the % of repeaters of Niger in 2003 to that in 2007?
Your answer should be compact. 0.76. What is the ratio of the % of repeaters of Latin America(developing only) in 2003 to that in 2008?
Offer a terse response. 1.04. What is the ratio of the % of repeaters of Armenia in 2003 to that in 2008?
Offer a terse response. 3.49. What is the ratio of the % of repeaters of Croatia in 2003 to that in 2008?
Keep it short and to the point. 1.06. What is the ratio of the % of repeaters in Niger in 2003 to that in 2008?
Your response must be concise. 0.87. What is the ratio of the % of repeaters in Latin America(developing only) in 2003 to that in 2009?
Your answer should be compact. 1.07. What is the ratio of the % of repeaters in Armenia in 2003 to that in 2009?
Provide a succinct answer. 2.99. What is the ratio of the % of repeaters in Croatia in 2003 to that in 2009?
Provide a short and direct response. 2.54. What is the ratio of the % of repeaters of Niger in 2003 to that in 2009?
Your answer should be very brief. 0.96. What is the ratio of the % of repeaters of Latin America(developing only) in 2003 to that in 2010?
Your response must be concise. 1.17. What is the ratio of the % of repeaters of Armenia in 2003 to that in 2010?
Provide a succinct answer. 3.31. What is the ratio of the % of repeaters of Croatia in 2003 to that in 2010?
Your answer should be very brief. 0.9. What is the ratio of the % of repeaters of Niger in 2003 to that in 2010?
Offer a terse response. 1.01. What is the ratio of the % of repeaters of Latin America(developing only) in 2005 to that in 2006?
Ensure brevity in your answer.  1.03. What is the ratio of the % of repeaters of Armenia in 2005 to that in 2006?
Your answer should be very brief. 1.07. What is the ratio of the % of repeaters of Croatia in 2005 to that in 2006?
Your answer should be very brief. 0.96. What is the ratio of the % of repeaters of Niger in 2005 to that in 2006?
Your answer should be compact. 1.07. What is the ratio of the % of repeaters in Latin America(developing only) in 2005 to that in 2007?
Offer a terse response. 1.08. What is the ratio of the % of repeaters in Armenia in 2005 to that in 2007?
Your answer should be very brief. 1.25. What is the ratio of the % of repeaters of Croatia in 2005 to that in 2007?
Make the answer very short. 0.98. What is the ratio of the % of repeaters in Niger in 2005 to that in 2007?
Offer a very short reply. 0.74. What is the ratio of the % of repeaters in Latin America(developing only) in 2005 to that in 2008?
Provide a short and direct response. 1.09. What is the ratio of the % of repeaters of Armenia in 2005 to that in 2008?
Ensure brevity in your answer.  3.16. What is the ratio of the % of repeaters of Croatia in 2005 to that in 2008?
Make the answer very short. 0.88. What is the ratio of the % of repeaters in Niger in 2005 to that in 2008?
Give a very brief answer. 0.85. What is the ratio of the % of repeaters in Latin America(developing only) in 2005 to that in 2009?
Provide a short and direct response. 1.13. What is the ratio of the % of repeaters of Armenia in 2005 to that in 2009?
Ensure brevity in your answer.  2.71. What is the ratio of the % of repeaters in Croatia in 2005 to that in 2009?
Keep it short and to the point. 2.11. What is the ratio of the % of repeaters of Niger in 2005 to that in 2009?
Your response must be concise. 0.93. What is the ratio of the % of repeaters in Latin America(developing only) in 2005 to that in 2010?
Ensure brevity in your answer.  1.23. What is the ratio of the % of repeaters in Armenia in 2005 to that in 2010?
Ensure brevity in your answer.  3. What is the ratio of the % of repeaters in Croatia in 2005 to that in 2010?
Ensure brevity in your answer.  0.75. What is the ratio of the % of repeaters in Niger in 2005 to that in 2010?
Your answer should be compact. 0.99. What is the ratio of the % of repeaters in Latin America(developing only) in 2006 to that in 2007?
Offer a very short reply. 1.04. What is the ratio of the % of repeaters in Armenia in 2006 to that in 2007?
Offer a terse response. 1.17. What is the ratio of the % of repeaters in Croatia in 2006 to that in 2007?
Offer a terse response. 1.02. What is the ratio of the % of repeaters of Niger in 2006 to that in 2007?
Keep it short and to the point. 0.69. What is the ratio of the % of repeaters of Latin America(developing only) in 2006 to that in 2008?
Ensure brevity in your answer.  1.06. What is the ratio of the % of repeaters in Armenia in 2006 to that in 2008?
Your answer should be compact. 2.95. What is the ratio of the % of repeaters of Croatia in 2006 to that in 2008?
Give a very brief answer. 0.92. What is the ratio of the % of repeaters of Niger in 2006 to that in 2008?
Offer a very short reply. 0.79. What is the ratio of the % of repeaters of Latin America(developing only) in 2006 to that in 2009?
Provide a succinct answer. 1.09. What is the ratio of the % of repeaters of Armenia in 2006 to that in 2009?
Make the answer very short. 2.53. What is the ratio of the % of repeaters in Croatia in 2006 to that in 2009?
Your answer should be very brief. 2.2. What is the ratio of the % of repeaters in Niger in 2006 to that in 2009?
Give a very brief answer. 0.87. What is the ratio of the % of repeaters in Latin America(developing only) in 2006 to that in 2010?
Your response must be concise. 1.19. What is the ratio of the % of repeaters in Armenia in 2006 to that in 2010?
Ensure brevity in your answer.  2.81. What is the ratio of the % of repeaters of Croatia in 2006 to that in 2010?
Your answer should be very brief. 0.78. What is the ratio of the % of repeaters of Niger in 2006 to that in 2010?
Offer a terse response. 0.92. What is the ratio of the % of repeaters of Latin America(developing only) in 2007 to that in 2008?
Offer a terse response. 1.01. What is the ratio of the % of repeaters of Armenia in 2007 to that in 2008?
Ensure brevity in your answer.  2.52. What is the ratio of the % of repeaters in Croatia in 2007 to that in 2008?
Provide a succinct answer. 0.9. What is the ratio of the % of repeaters in Niger in 2007 to that in 2008?
Provide a succinct answer. 1.15. What is the ratio of the % of repeaters in Latin America(developing only) in 2007 to that in 2009?
Your response must be concise. 1.05. What is the ratio of the % of repeaters of Armenia in 2007 to that in 2009?
Your answer should be very brief. 2.16. What is the ratio of the % of repeaters of Croatia in 2007 to that in 2009?
Ensure brevity in your answer.  2.15. What is the ratio of the % of repeaters in Niger in 2007 to that in 2009?
Give a very brief answer. 1.26. What is the ratio of the % of repeaters of Latin America(developing only) in 2007 to that in 2010?
Provide a short and direct response. 1.14. What is the ratio of the % of repeaters in Armenia in 2007 to that in 2010?
Provide a short and direct response. 2.4. What is the ratio of the % of repeaters of Croatia in 2007 to that in 2010?
Your answer should be compact. 0.76. What is the ratio of the % of repeaters in Niger in 2007 to that in 2010?
Your response must be concise. 1.33. What is the ratio of the % of repeaters in Latin America(developing only) in 2008 to that in 2009?
Make the answer very short. 1.03. What is the ratio of the % of repeaters of Armenia in 2008 to that in 2009?
Your answer should be compact. 0.86. What is the ratio of the % of repeaters of Croatia in 2008 to that in 2009?
Give a very brief answer. 2.4. What is the ratio of the % of repeaters in Niger in 2008 to that in 2009?
Give a very brief answer. 1.1. What is the ratio of the % of repeaters in Latin America(developing only) in 2008 to that in 2010?
Ensure brevity in your answer.  1.12. What is the ratio of the % of repeaters of Armenia in 2008 to that in 2010?
Ensure brevity in your answer.  0.95. What is the ratio of the % of repeaters in Croatia in 2008 to that in 2010?
Make the answer very short. 0.85. What is the ratio of the % of repeaters of Niger in 2008 to that in 2010?
Your answer should be compact. 1.16. What is the ratio of the % of repeaters of Latin America(developing only) in 2009 to that in 2010?
Your response must be concise. 1.09. What is the ratio of the % of repeaters in Armenia in 2009 to that in 2010?
Offer a very short reply. 1.11. What is the ratio of the % of repeaters of Croatia in 2009 to that in 2010?
Keep it short and to the point. 0.36. What is the ratio of the % of repeaters in Niger in 2009 to that in 2010?
Your response must be concise. 1.06. What is the difference between the highest and the second highest % of repeaters of Latin America(developing only)?
Offer a terse response. 0.47. What is the difference between the highest and the second highest % of repeaters in Armenia?
Your answer should be very brief. 0.04. What is the difference between the highest and the second highest % of repeaters of Croatia?
Ensure brevity in your answer.  0.02. What is the difference between the highest and the second highest % of repeaters in Niger?
Make the answer very short. 2.31. What is the difference between the highest and the lowest % of repeaters of Latin America(developing only)?
Keep it short and to the point. 2.64. What is the difference between the highest and the lowest % of repeaters of Armenia?
Make the answer very short. 0.32. What is the difference between the highest and the lowest % of repeaters in Croatia?
Offer a terse response. 0.59. What is the difference between the highest and the lowest % of repeaters of Niger?
Keep it short and to the point. 7.68. 